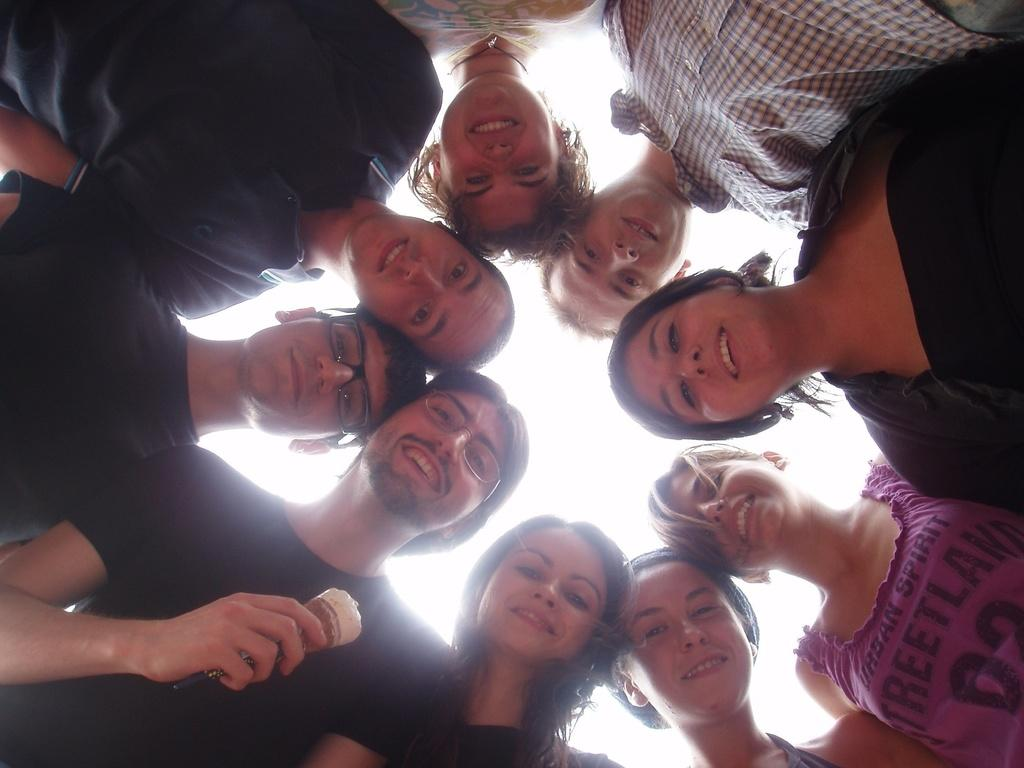How many people are in the image? There are people in the image, but the exact number is not specified. What is the arrangement of the people in the image? The people are in a circle in the image. What is the emotional expression of the people in the image? The people are smiling in the image. What is the man holding in the image? The man is holding an ice cream in the image. On which side of the image is the man standing? The man is standing on the left side in the image. What can be seen in the background of the image? There is sky visible in the background of the image. What impulse is causing the people to point at the scent in the image? There is no mention of an impulse, pointing, or scent in the image. The people are simply smiling and standing in a circle. 